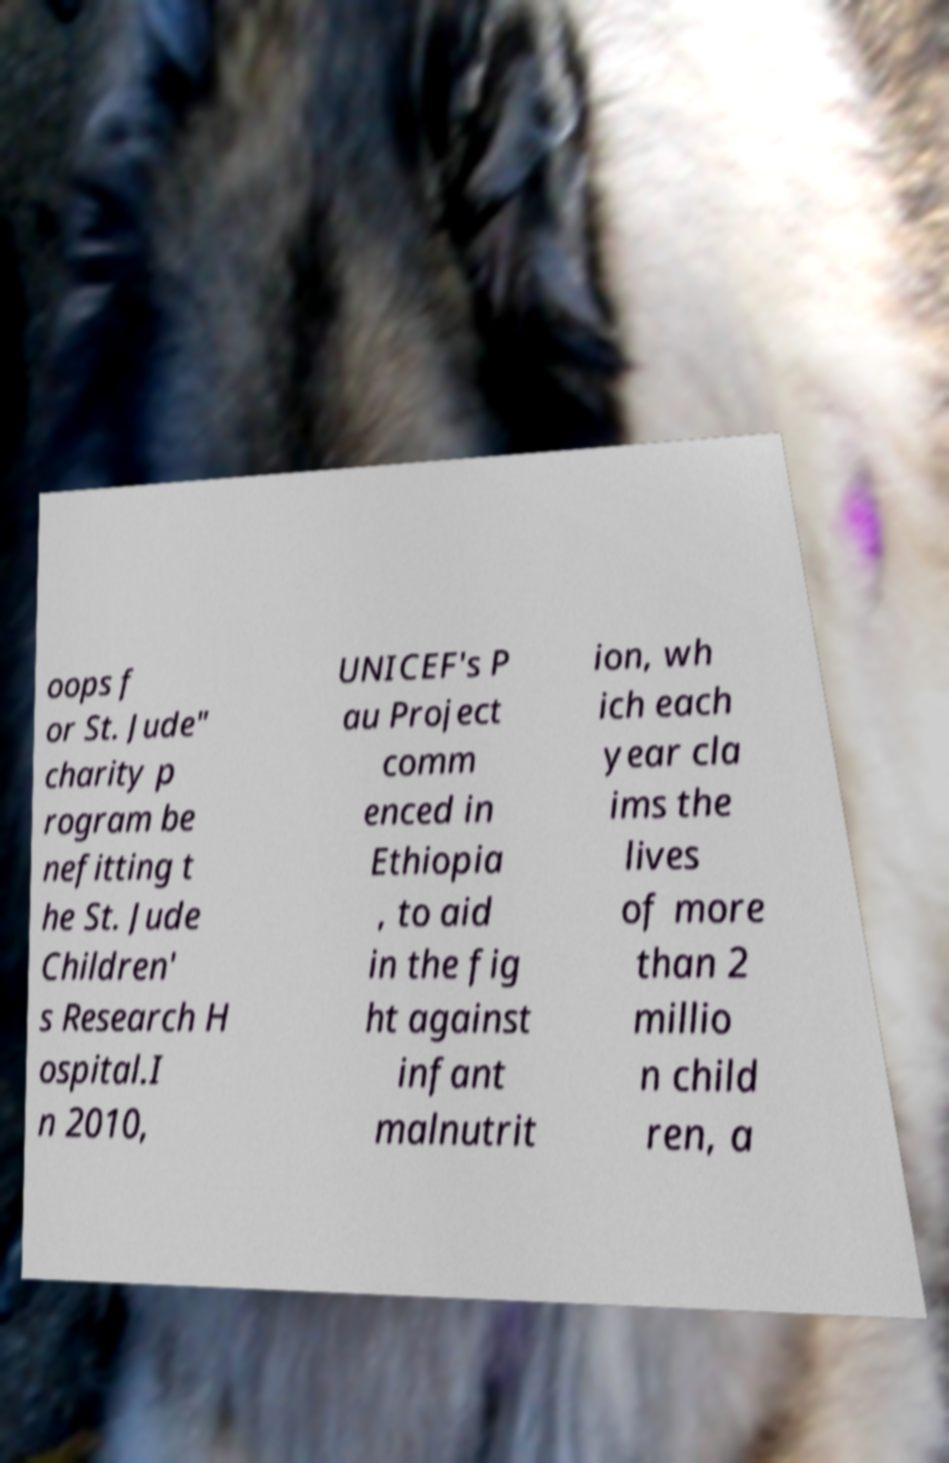For documentation purposes, I need the text within this image transcribed. Could you provide that? oops f or St. Jude" charity p rogram be nefitting t he St. Jude Children' s Research H ospital.I n 2010, UNICEF's P au Project comm enced in Ethiopia , to aid in the fig ht against infant malnutrit ion, wh ich each year cla ims the lives of more than 2 millio n child ren, a 